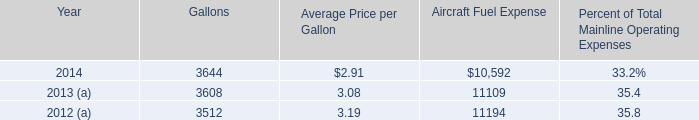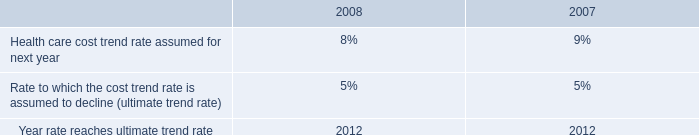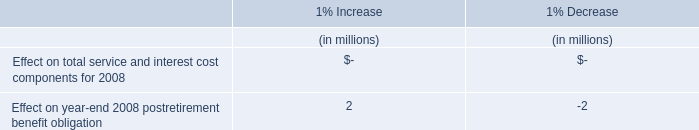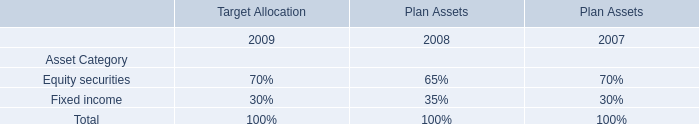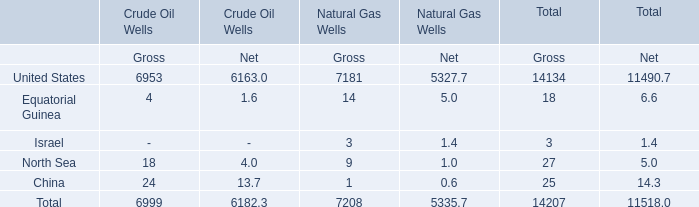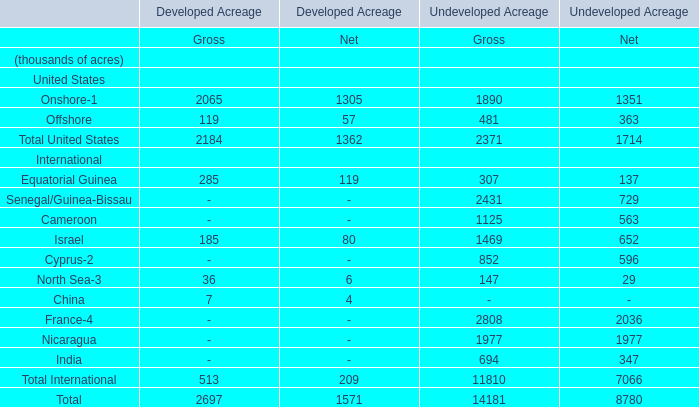What's the total amount of the Equatorial Guinea and Israel in the years where Gross is greater than 7000? 
Computations: (14 + 3)
Answer: 17.0. 